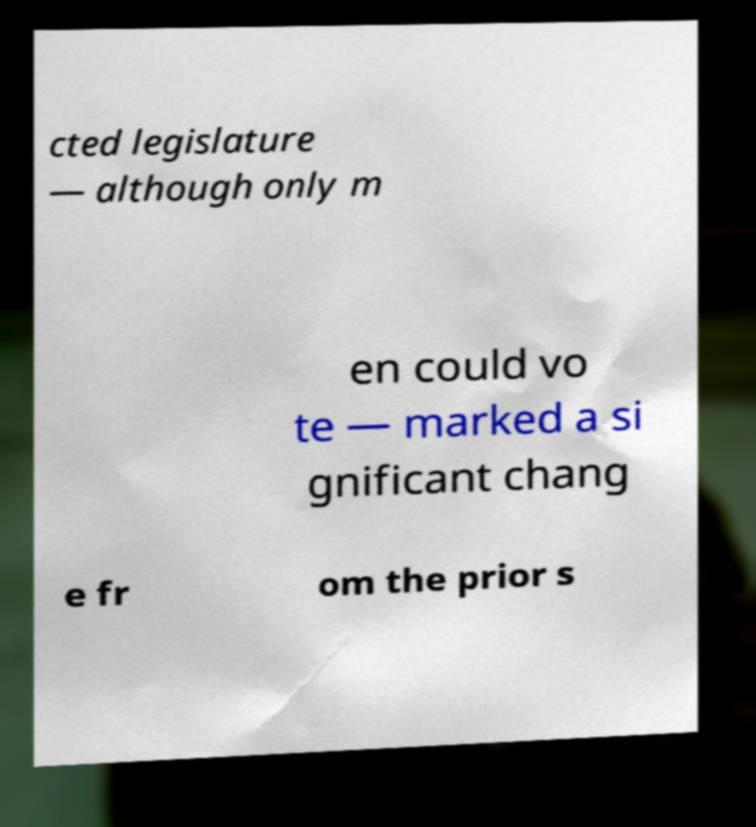Can you read and provide the text displayed in the image?This photo seems to have some interesting text. Can you extract and type it out for me? cted legislature — although only m en could vo te — marked a si gnificant chang e fr om the prior s 